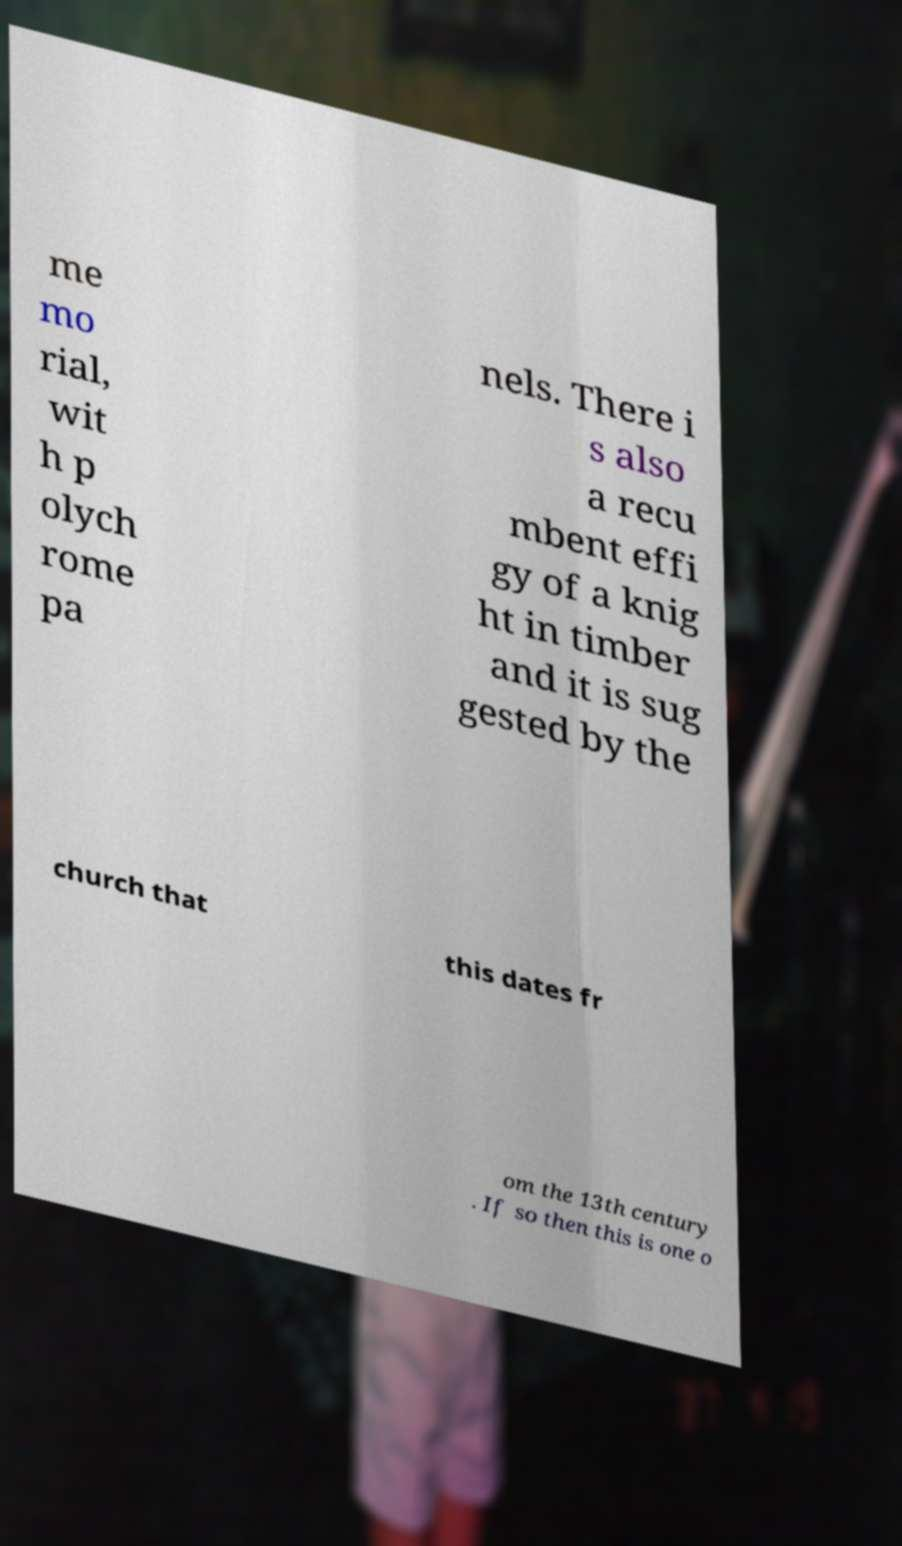There's text embedded in this image that I need extracted. Can you transcribe it verbatim? me mo rial, wit h p olych rome pa nels. There i s also a recu mbent effi gy of a knig ht in timber and it is sug gested by the church that this dates fr om the 13th century . If so then this is one o 